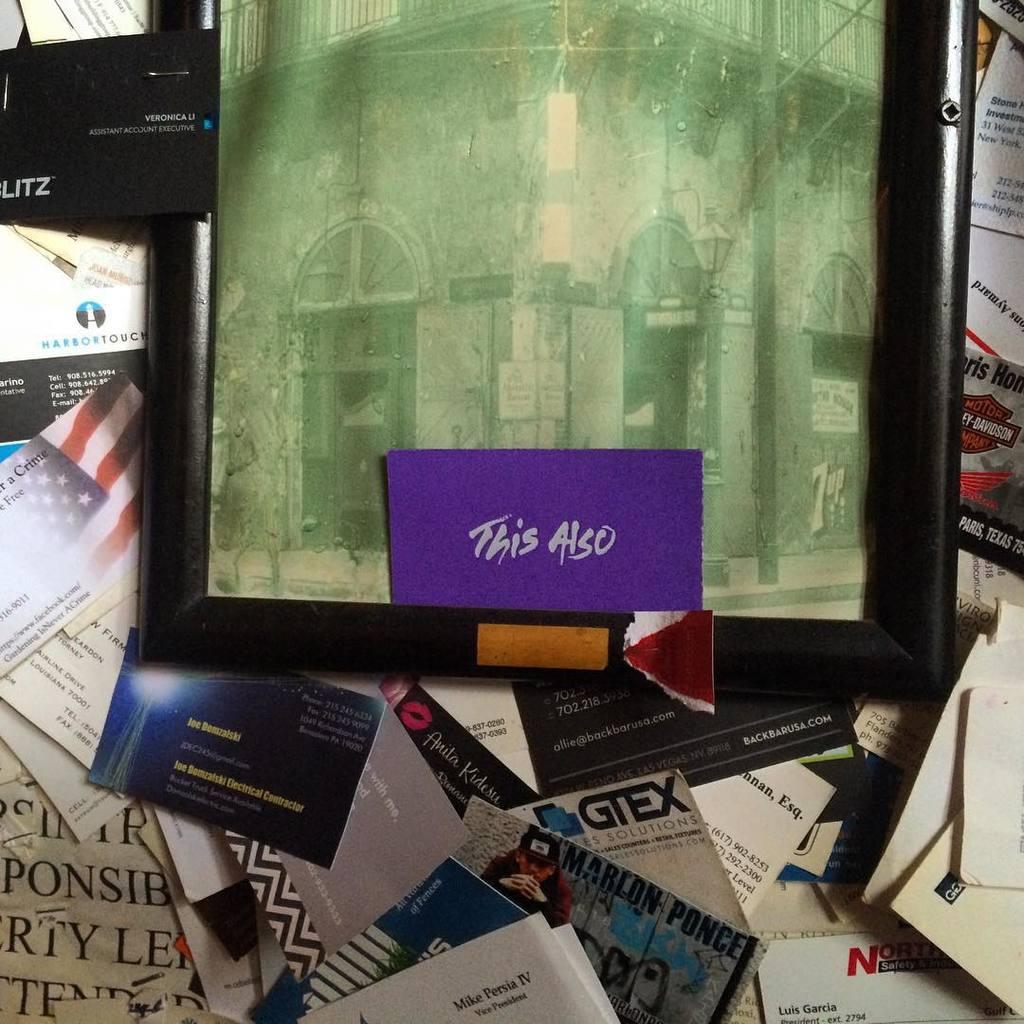What does the purple envelope say?
Make the answer very short. This also. 